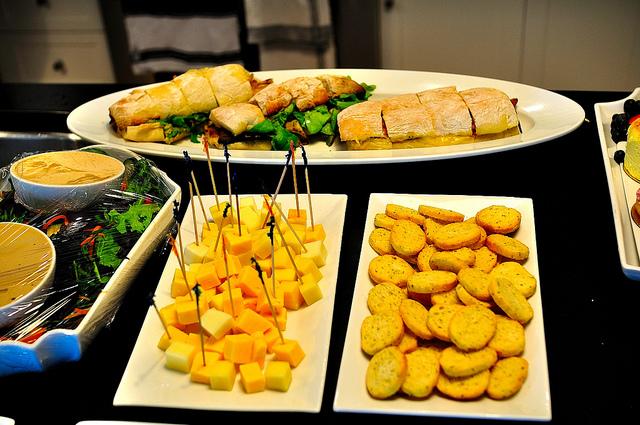Are the dips ready to be eaten?
Quick response, please. No. Are there vegetarian options available?
Concise answer only. Yes. What are the toothpicks used for in this picture?
Quick response, please. Hold cheese. 